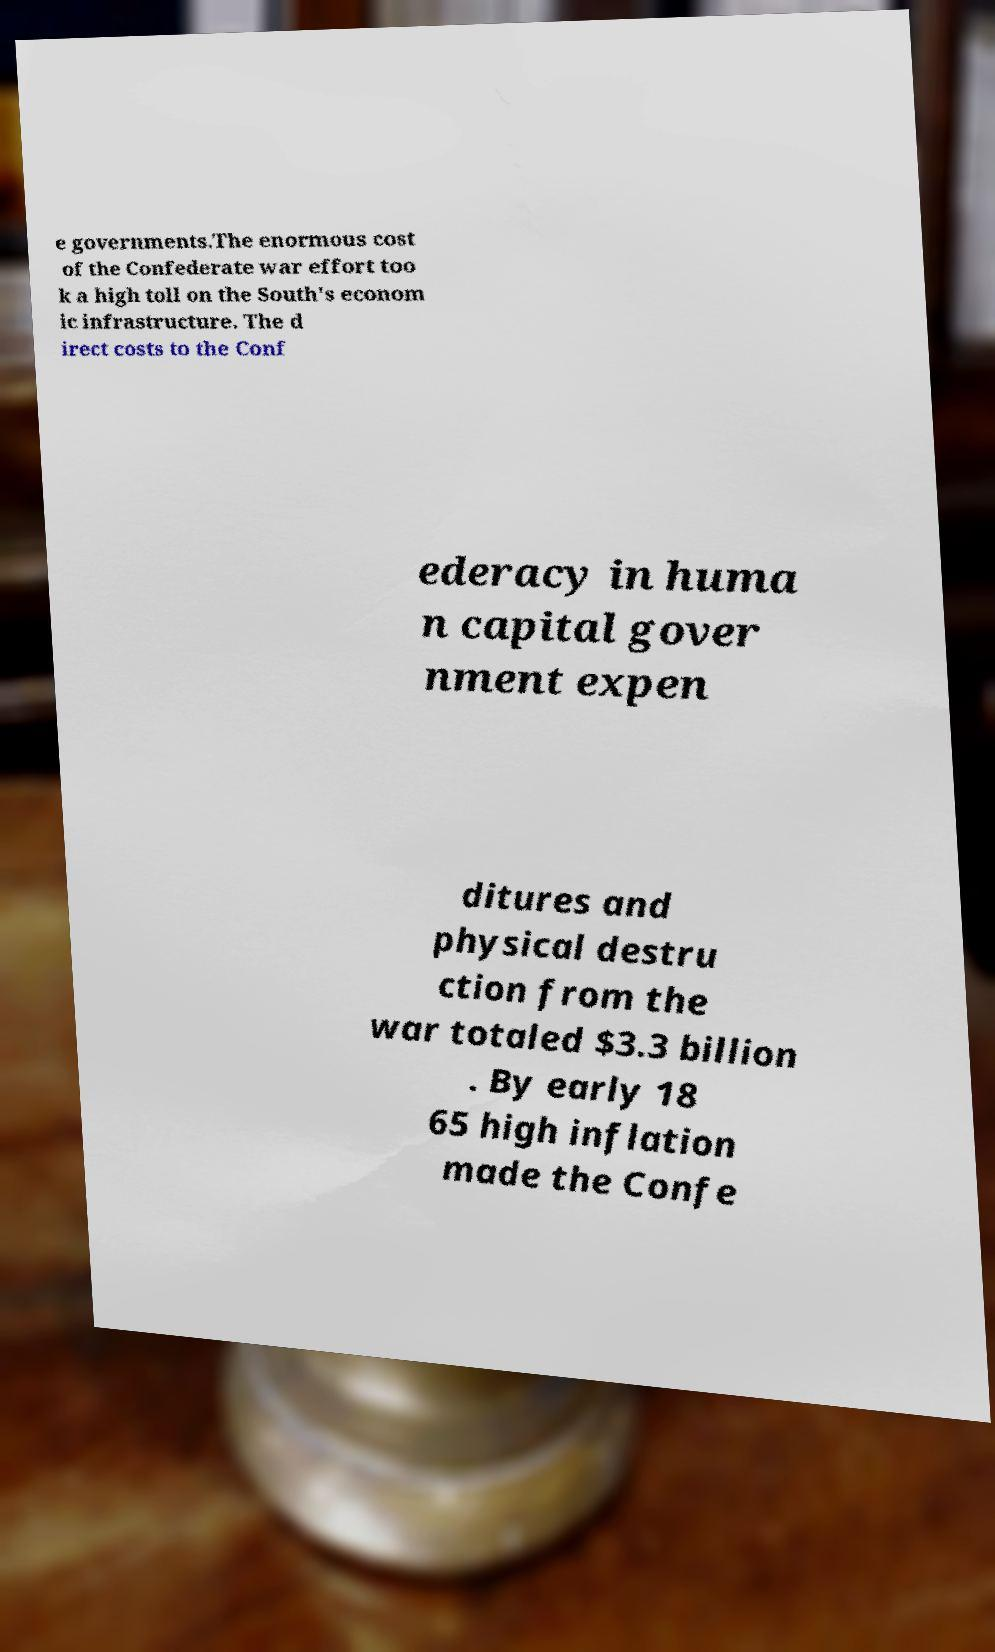Could you extract and type out the text from this image? e governments.The enormous cost of the Confederate war effort too k a high toll on the South's econom ic infrastructure. The d irect costs to the Conf ederacy in huma n capital gover nment expen ditures and physical destru ction from the war totaled $3.3 billion . By early 18 65 high inflation made the Confe 